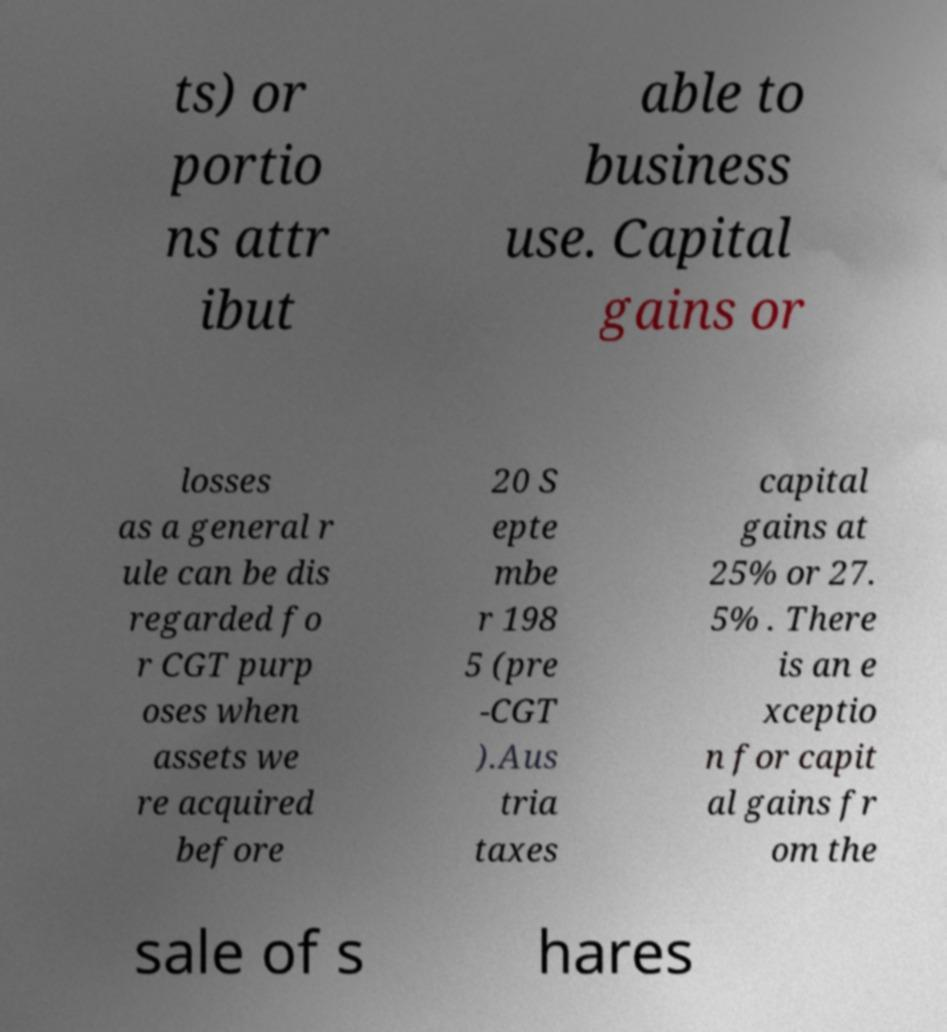Can you accurately transcribe the text from the provided image for me? ts) or portio ns attr ibut able to business use. Capital gains or losses as a general r ule can be dis regarded fo r CGT purp oses when assets we re acquired before 20 S epte mbe r 198 5 (pre -CGT ).Aus tria taxes capital gains at 25% or 27. 5% . There is an e xceptio n for capit al gains fr om the sale of s hares 